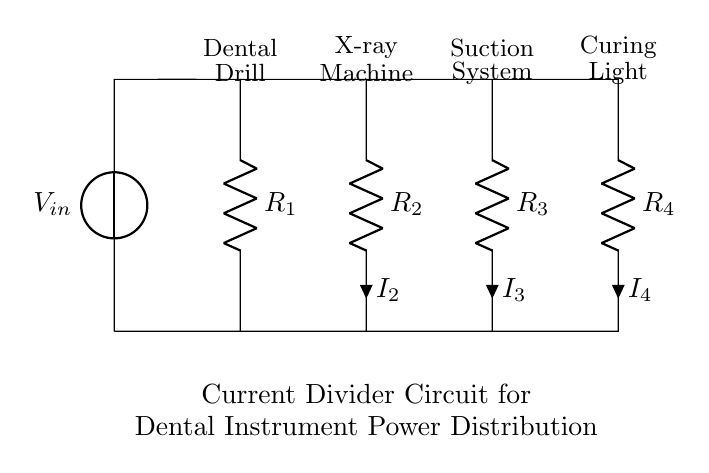What is the input voltage of this circuit? The input voltage is indicated by the voltage source at the left side of the circuit, labeled as V_in.
Answer: V_in How many resistors are in the circuit? The circuit diagram shows four resistors labeled R_1, R_2, R_3, and R_4, which are connected in parallel.
Answer: Four What is the current through resistor R_2? The current through resistor R_2 is labeled as I_2, which is shown in the circuit diagram beside R_2.
Answer: I_2 Which dental instrument has the highest resistance? Since the resistors are in parallel, the instrument with the highest resistance corresponds to the one with the smallest current. You would analyze the circuit to determine this; however, based on typical usage, the dental drill, R_1, is often associated with higher power demand.
Answer: Dental Drill (R_1) How does the current divide among the resistors? In a current divider circuit, the total input current splits among the parallel resistors inversely proportional to their resistance values. Therefore, the higher the resistance of a resistor, the smaller the current flowing through it compared to those with lower resistance. For example, R_1 (the dental drill) may draw more current than R_4 (the curing light).
Answer: Inversely proportional to resistance 